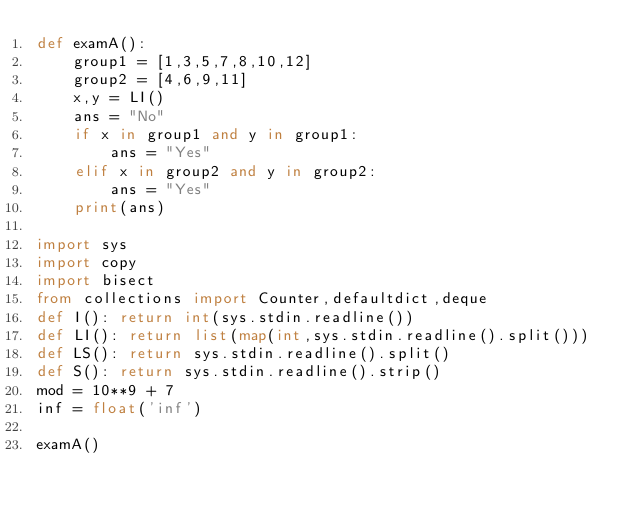Convert code to text. <code><loc_0><loc_0><loc_500><loc_500><_Python_>def examA():
    group1 = [1,3,5,7,8,10,12]
    group2 = [4,6,9,11]
    x,y = LI()
    ans = "No"
    if x in group1 and y in group1:
        ans = "Yes"
    elif x in group2 and y in group2:
        ans = "Yes"
    print(ans)

import sys
import copy
import bisect
from collections import Counter,defaultdict,deque
def I(): return int(sys.stdin.readline())
def LI(): return list(map(int,sys.stdin.readline().split()))
def LS(): return sys.stdin.readline().split()
def S(): return sys.stdin.readline().strip()
mod = 10**9 + 7
inf = float('inf')

examA()
</code> 